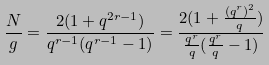Convert formula to latex. <formula><loc_0><loc_0><loc_500><loc_500>\frac { N } { g } = \frac { 2 ( 1 + q ^ { 2 r - 1 } ) } { q ^ { r - 1 } ( q ^ { r - 1 } - 1 ) } = \frac { 2 ( 1 + \frac { ( q ^ { r } ) ^ { 2 } } { q } ) } { \frac { q ^ { r } } { q } ( \frac { q ^ { r } } { q } - 1 ) }</formula> 